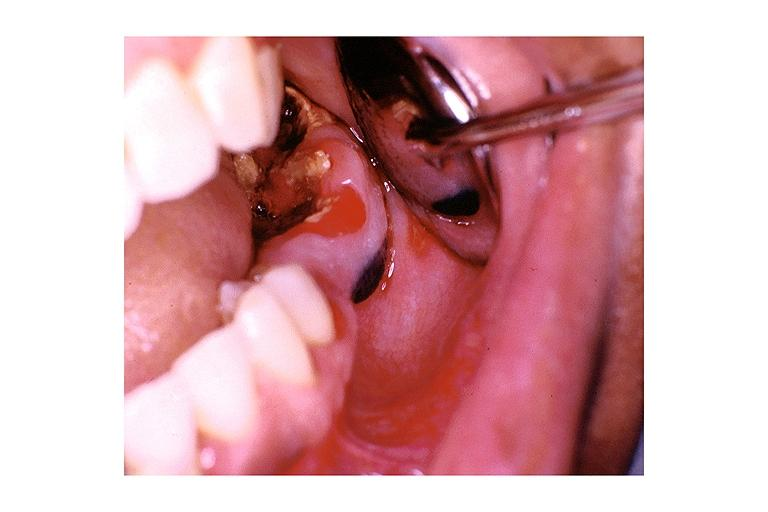s cut surface typical ivory vertebra do not have history at this time diagnosis present?
Answer the question using a single word or phrase. No 